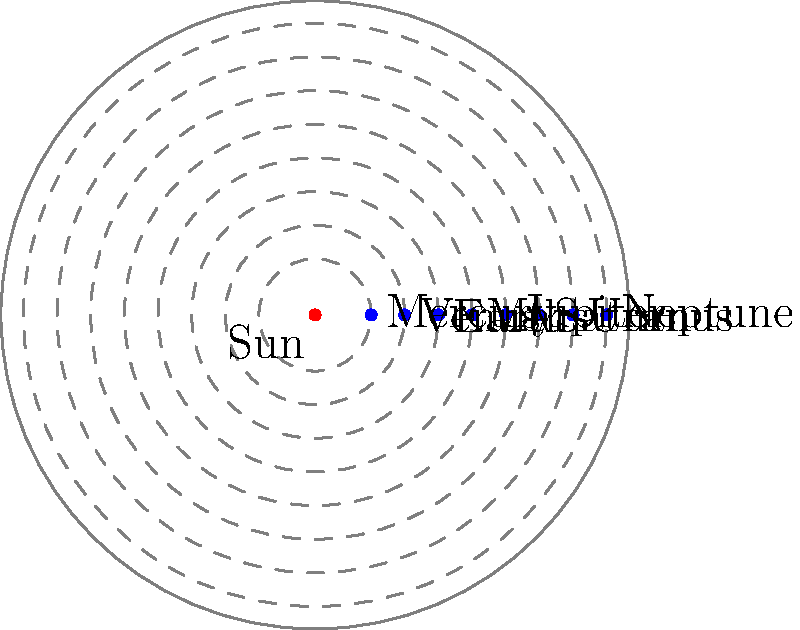In the simplified orbital map of our solar system, which planet's orbit would you need to modify in a Smarty template to represent the most eccentric (least circular) orbit, and why might this be important for optimizing page load times using GZIP compression? To answer this question, let's break it down step-by-step:

1. Eccentricity in orbital mechanics:
   - Eccentricity measures how much an orbit deviates from a perfect circle.
   - A perfect circle has an eccentricity of 0, while more elliptical orbits have values approaching 1.

2. Most eccentric orbit in our solar system:
   - Among the planets, Mercury has the most eccentric orbit with an eccentricity of about 0.206.
   - Other planets have more circular orbits, with eccentricities closer to 0.

3. Modifying the orbit in a Smarty template:
   - In a Smarty template, you might represent the orbit using SVG or canvas elements.
   - To show Mercury's eccentric orbit, you'd need to modify its path from a circle to an ellipse.

4. Impact on GZIP compression and page load times:
   - GZIP compression works by finding and encoding repeating patterns in data.
   - Circular orbits (represented by perfect circles) are more likely to have repeating patterns in their code.
   - An elliptical orbit for Mercury would introduce unique values, potentially reducing GZIP compression efficiency.

5. Optimization considerations:
   - While accurately representing Mercury's orbit is important for educational purposes, it might slightly increase the file size after compression.
   - However, the impact would be minimal, and the educational value likely outweighs the tiny increase in page load time.

6. Web development perspective:
   - As a web developer, you'd need to balance accuracy of representation with performance optimization.
   - You might consider using JavaScript to dynamically generate the eccentric orbit, which could be more efficiently compressed than static SVG or canvas elements.
Answer: Mercury; eccentric orbit reduces repeating patterns, slightly affecting GZIP compression efficiency. 